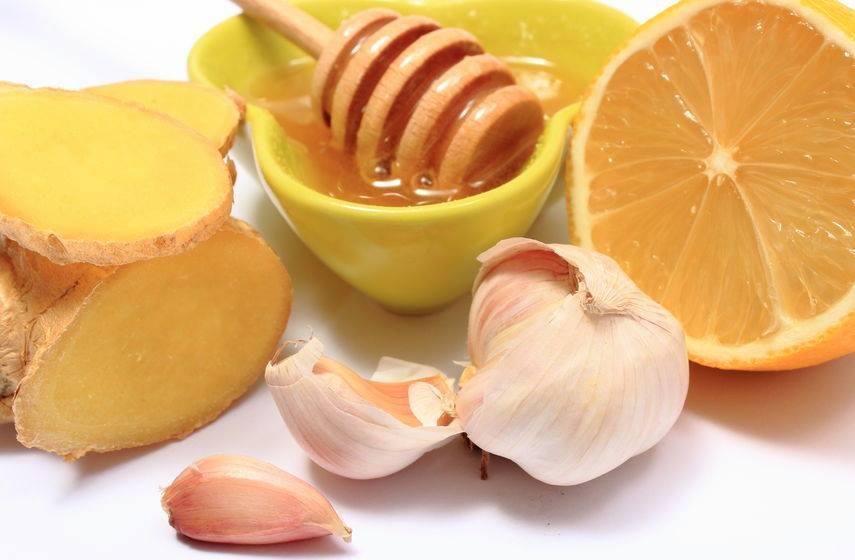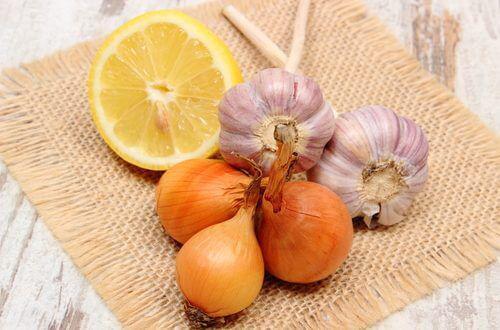The first image is the image on the left, the second image is the image on the right. For the images displayed, is the sentence "One picture has atleast 2 full cloves of garlic and 2 full onions" factually correct? Answer yes or no. Yes. The first image is the image on the left, the second image is the image on the right. For the images shown, is this caption "In one image, half a lemon, onions and some garlic are on a square mat." true? Answer yes or no. Yes. 